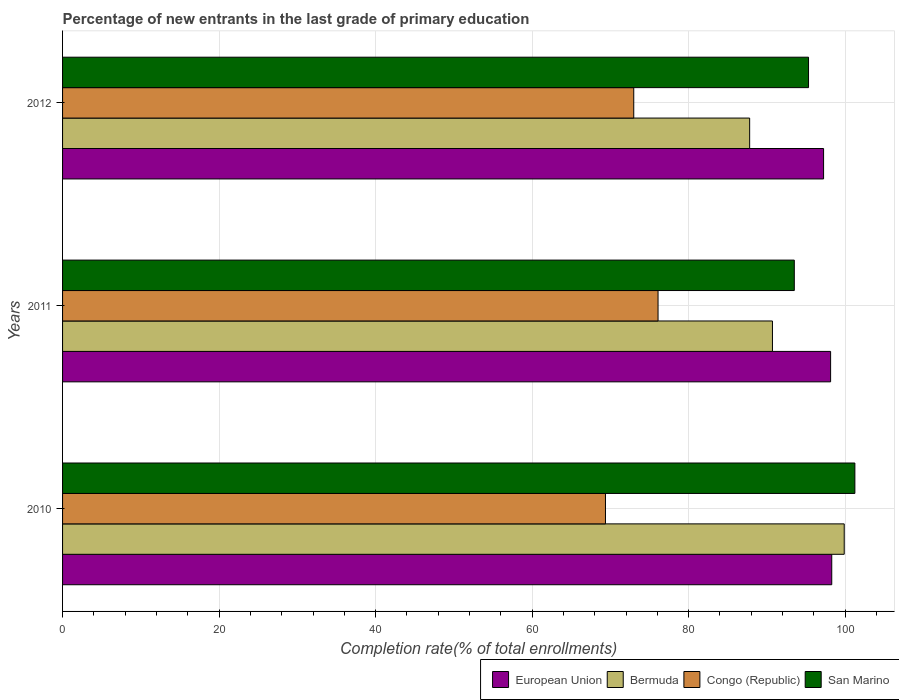How many bars are there on the 3rd tick from the top?
Your response must be concise. 4. How many bars are there on the 1st tick from the bottom?
Make the answer very short. 4. What is the label of the 1st group of bars from the top?
Provide a short and direct response. 2012. What is the percentage of new entrants in European Union in 2011?
Your response must be concise. 98.14. Across all years, what is the maximum percentage of new entrants in San Marino?
Provide a succinct answer. 101.24. Across all years, what is the minimum percentage of new entrants in Bermuda?
Keep it short and to the point. 87.79. In which year was the percentage of new entrants in Bermuda minimum?
Offer a very short reply. 2012. What is the total percentage of new entrants in San Marino in the graph?
Provide a short and direct response. 290.05. What is the difference between the percentage of new entrants in San Marino in 2010 and that in 2012?
Keep it short and to the point. 5.92. What is the difference between the percentage of new entrants in European Union in 2011 and the percentage of new entrants in Bermuda in 2012?
Provide a short and direct response. 10.34. What is the average percentage of new entrants in European Union per year?
Your answer should be very brief. 97.89. In the year 2012, what is the difference between the percentage of new entrants in European Union and percentage of new entrants in San Marino?
Your answer should be compact. 1.92. What is the ratio of the percentage of new entrants in San Marino in 2010 to that in 2012?
Keep it short and to the point. 1.06. Is the percentage of new entrants in Congo (Republic) in 2010 less than that in 2012?
Your response must be concise. Yes. What is the difference between the highest and the second highest percentage of new entrants in San Marino?
Your response must be concise. 5.92. What is the difference between the highest and the lowest percentage of new entrants in San Marino?
Provide a succinct answer. 7.74. In how many years, is the percentage of new entrants in San Marino greater than the average percentage of new entrants in San Marino taken over all years?
Provide a short and direct response. 1. What does the 1st bar from the top in 2010 represents?
Your answer should be compact. San Marino. How many years are there in the graph?
Provide a short and direct response. 3. What is the difference between two consecutive major ticks on the X-axis?
Make the answer very short. 20. Does the graph contain any zero values?
Provide a succinct answer. No. Does the graph contain grids?
Offer a terse response. Yes. Where does the legend appear in the graph?
Provide a short and direct response. Bottom right. What is the title of the graph?
Ensure brevity in your answer.  Percentage of new entrants in the last grade of primary education. What is the label or title of the X-axis?
Offer a terse response. Completion rate(% of total enrollments). What is the label or title of the Y-axis?
Make the answer very short. Years. What is the Completion rate(% of total enrollments) of European Union in 2010?
Give a very brief answer. 98.28. What is the Completion rate(% of total enrollments) in Bermuda in 2010?
Offer a terse response. 99.88. What is the Completion rate(% of total enrollments) of Congo (Republic) in 2010?
Your answer should be compact. 69.37. What is the Completion rate(% of total enrollments) of San Marino in 2010?
Your answer should be very brief. 101.24. What is the Completion rate(% of total enrollments) of European Union in 2011?
Provide a short and direct response. 98.14. What is the Completion rate(% of total enrollments) of Bermuda in 2011?
Keep it short and to the point. 90.71. What is the Completion rate(% of total enrollments) of Congo (Republic) in 2011?
Your answer should be compact. 76.09. What is the Completion rate(% of total enrollments) in San Marino in 2011?
Your answer should be compact. 93.5. What is the Completion rate(% of total enrollments) in European Union in 2012?
Ensure brevity in your answer.  97.24. What is the Completion rate(% of total enrollments) in Bermuda in 2012?
Keep it short and to the point. 87.79. What is the Completion rate(% of total enrollments) of Congo (Republic) in 2012?
Ensure brevity in your answer.  72.98. What is the Completion rate(% of total enrollments) of San Marino in 2012?
Your response must be concise. 95.32. Across all years, what is the maximum Completion rate(% of total enrollments) in European Union?
Provide a short and direct response. 98.28. Across all years, what is the maximum Completion rate(% of total enrollments) of Bermuda?
Your answer should be compact. 99.88. Across all years, what is the maximum Completion rate(% of total enrollments) in Congo (Republic)?
Your answer should be very brief. 76.09. Across all years, what is the maximum Completion rate(% of total enrollments) of San Marino?
Provide a short and direct response. 101.24. Across all years, what is the minimum Completion rate(% of total enrollments) in European Union?
Your answer should be compact. 97.24. Across all years, what is the minimum Completion rate(% of total enrollments) in Bermuda?
Make the answer very short. 87.79. Across all years, what is the minimum Completion rate(% of total enrollments) of Congo (Republic)?
Provide a short and direct response. 69.37. Across all years, what is the minimum Completion rate(% of total enrollments) in San Marino?
Keep it short and to the point. 93.5. What is the total Completion rate(% of total enrollments) of European Union in the graph?
Your response must be concise. 293.66. What is the total Completion rate(% of total enrollments) of Bermuda in the graph?
Provide a short and direct response. 278.37. What is the total Completion rate(% of total enrollments) in Congo (Republic) in the graph?
Your answer should be compact. 218.44. What is the total Completion rate(% of total enrollments) in San Marino in the graph?
Your response must be concise. 290.05. What is the difference between the Completion rate(% of total enrollments) of European Union in 2010 and that in 2011?
Give a very brief answer. 0.15. What is the difference between the Completion rate(% of total enrollments) in Bermuda in 2010 and that in 2011?
Ensure brevity in your answer.  9.17. What is the difference between the Completion rate(% of total enrollments) of Congo (Republic) in 2010 and that in 2011?
Your answer should be very brief. -6.72. What is the difference between the Completion rate(% of total enrollments) in San Marino in 2010 and that in 2011?
Provide a succinct answer. 7.74. What is the difference between the Completion rate(% of total enrollments) of European Union in 2010 and that in 2012?
Keep it short and to the point. 1.04. What is the difference between the Completion rate(% of total enrollments) of Bermuda in 2010 and that in 2012?
Make the answer very short. 12.08. What is the difference between the Completion rate(% of total enrollments) of Congo (Republic) in 2010 and that in 2012?
Provide a succinct answer. -3.61. What is the difference between the Completion rate(% of total enrollments) in San Marino in 2010 and that in 2012?
Your answer should be compact. 5.92. What is the difference between the Completion rate(% of total enrollments) in European Union in 2011 and that in 2012?
Your answer should be compact. 0.9. What is the difference between the Completion rate(% of total enrollments) of Bermuda in 2011 and that in 2012?
Give a very brief answer. 2.91. What is the difference between the Completion rate(% of total enrollments) of Congo (Republic) in 2011 and that in 2012?
Offer a very short reply. 3.11. What is the difference between the Completion rate(% of total enrollments) of San Marino in 2011 and that in 2012?
Your response must be concise. -1.82. What is the difference between the Completion rate(% of total enrollments) in European Union in 2010 and the Completion rate(% of total enrollments) in Bermuda in 2011?
Provide a short and direct response. 7.58. What is the difference between the Completion rate(% of total enrollments) of European Union in 2010 and the Completion rate(% of total enrollments) of Congo (Republic) in 2011?
Offer a very short reply. 22.19. What is the difference between the Completion rate(% of total enrollments) of European Union in 2010 and the Completion rate(% of total enrollments) of San Marino in 2011?
Keep it short and to the point. 4.78. What is the difference between the Completion rate(% of total enrollments) in Bermuda in 2010 and the Completion rate(% of total enrollments) in Congo (Republic) in 2011?
Make the answer very short. 23.79. What is the difference between the Completion rate(% of total enrollments) of Bermuda in 2010 and the Completion rate(% of total enrollments) of San Marino in 2011?
Keep it short and to the point. 6.38. What is the difference between the Completion rate(% of total enrollments) of Congo (Republic) in 2010 and the Completion rate(% of total enrollments) of San Marino in 2011?
Offer a very short reply. -24.13. What is the difference between the Completion rate(% of total enrollments) in European Union in 2010 and the Completion rate(% of total enrollments) in Bermuda in 2012?
Offer a terse response. 10.49. What is the difference between the Completion rate(% of total enrollments) of European Union in 2010 and the Completion rate(% of total enrollments) of Congo (Republic) in 2012?
Offer a very short reply. 25.3. What is the difference between the Completion rate(% of total enrollments) in European Union in 2010 and the Completion rate(% of total enrollments) in San Marino in 2012?
Make the answer very short. 2.97. What is the difference between the Completion rate(% of total enrollments) in Bermuda in 2010 and the Completion rate(% of total enrollments) in Congo (Republic) in 2012?
Make the answer very short. 26.89. What is the difference between the Completion rate(% of total enrollments) of Bermuda in 2010 and the Completion rate(% of total enrollments) of San Marino in 2012?
Your response must be concise. 4.56. What is the difference between the Completion rate(% of total enrollments) in Congo (Republic) in 2010 and the Completion rate(% of total enrollments) in San Marino in 2012?
Provide a succinct answer. -25.95. What is the difference between the Completion rate(% of total enrollments) in European Union in 2011 and the Completion rate(% of total enrollments) in Bermuda in 2012?
Your answer should be compact. 10.34. What is the difference between the Completion rate(% of total enrollments) of European Union in 2011 and the Completion rate(% of total enrollments) of Congo (Republic) in 2012?
Give a very brief answer. 25.15. What is the difference between the Completion rate(% of total enrollments) in European Union in 2011 and the Completion rate(% of total enrollments) in San Marino in 2012?
Offer a very short reply. 2.82. What is the difference between the Completion rate(% of total enrollments) of Bermuda in 2011 and the Completion rate(% of total enrollments) of Congo (Republic) in 2012?
Ensure brevity in your answer.  17.72. What is the difference between the Completion rate(% of total enrollments) of Bermuda in 2011 and the Completion rate(% of total enrollments) of San Marino in 2012?
Offer a very short reply. -4.61. What is the difference between the Completion rate(% of total enrollments) of Congo (Republic) in 2011 and the Completion rate(% of total enrollments) of San Marino in 2012?
Offer a very short reply. -19.23. What is the average Completion rate(% of total enrollments) of European Union per year?
Offer a terse response. 97.89. What is the average Completion rate(% of total enrollments) in Bermuda per year?
Provide a short and direct response. 92.79. What is the average Completion rate(% of total enrollments) in Congo (Republic) per year?
Offer a terse response. 72.81. What is the average Completion rate(% of total enrollments) of San Marino per year?
Make the answer very short. 96.68. In the year 2010, what is the difference between the Completion rate(% of total enrollments) in European Union and Completion rate(% of total enrollments) in Bermuda?
Your answer should be compact. -1.59. In the year 2010, what is the difference between the Completion rate(% of total enrollments) in European Union and Completion rate(% of total enrollments) in Congo (Republic)?
Give a very brief answer. 28.91. In the year 2010, what is the difference between the Completion rate(% of total enrollments) in European Union and Completion rate(% of total enrollments) in San Marino?
Offer a terse response. -2.96. In the year 2010, what is the difference between the Completion rate(% of total enrollments) of Bermuda and Completion rate(% of total enrollments) of Congo (Republic)?
Your answer should be very brief. 30.51. In the year 2010, what is the difference between the Completion rate(% of total enrollments) of Bermuda and Completion rate(% of total enrollments) of San Marino?
Make the answer very short. -1.36. In the year 2010, what is the difference between the Completion rate(% of total enrollments) of Congo (Republic) and Completion rate(% of total enrollments) of San Marino?
Provide a short and direct response. -31.87. In the year 2011, what is the difference between the Completion rate(% of total enrollments) in European Union and Completion rate(% of total enrollments) in Bermuda?
Provide a succinct answer. 7.43. In the year 2011, what is the difference between the Completion rate(% of total enrollments) in European Union and Completion rate(% of total enrollments) in Congo (Republic)?
Ensure brevity in your answer.  22.05. In the year 2011, what is the difference between the Completion rate(% of total enrollments) of European Union and Completion rate(% of total enrollments) of San Marino?
Provide a succinct answer. 4.64. In the year 2011, what is the difference between the Completion rate(% of total enrollments) in Bermuda and Completion rate(% of total enrollments) in Congo (Republic)?
Keep it short and to the point. 14.62. In the year 2011, what is the difference between the Completion rate(% of total enrollments) in Bermuda and Completion rate(% of total enrollments) in San Marino?
Make the answer very short. -2.79. In the year 2011, what is the difference between the Completion rate(% of total enrollments) in Congo (Republic) and Completion rate(% of total enrollments) in San Marino?
Your answer should be compact. -17.41. In the year 2012, what is the difference between the Completion rate(% of total enrollments) in European Union and Completion rate(% of total enrollments) in Bermuda?
Your response must be concise. 9.45. In the year 2012, what is the difference between the Completion rate(% of total enrollments) of European Union and Completion rate(% of total enrollments) of Congo (Republic)?
Ensure brevity in your answer.  24.26. In the year 2012, what is the difference between the Completion rate(% of total enrollments) in European Union and Completion rate(% of total enrollments) in San Marino?
Your answer should be very brief. 1.92. In the year 2012, what is the difference between the Completion rate(% of total enrollments) of Bermuda and Completion rate(% of total enrollments) of Congo (Republic)?
Provide a short and direct response. 14.81. In the year 2012, what is the difference between the Completion rate(% of total enrollments) in Bermuda and Completion rate(% of total enrollments) in San Marino?
Keep it short and to the point. -7.52. In the year 2012, what is the difference between the Completion rate(% of total enrollments) in Congo (Republic) and Completion rate(% of total enrollments) in San Marino?
Provide a short and direct response. -22.33. What is the ratio of the Completion rate(% of total enrollments) of Bermuda in 2010 to that in 2011?
Your answer should be very brief. 1.1. What is the ratio of the Completion rate(% of total enrollments) in Congo (Republic) in 2010 to that in 2011?
Give a very brief answer. 0.91. What is the ratio of the Completion rate(% of total enrollments) of San Marino in 2010 to that in 2011?
Provide a succinct answer. 1.08. What is the ratio of the Completion rate(% of total enrollments) in European Union in 2010 to that in 2012?
Provide a succinct answer. 1.01. What is the ratio of the Completion rate(% of total enrollments) of Bermuda in 2010 to that in 2012?
Offer a terse response. 1.14. What is the ratio of the Completion rate(% of total enrollments) of Congo (Republic) in 2010 to that in 2012?
Offer a terse response. 0.95. What is the ratio of the Completion rate(% of total enrollments) in San Marino in 2010 to that in 2012?
Ensure brevity in your answer.  1.06. What is the ratio of the Completion rate(% of total enrollments) of European Union in 2011 to that in 2012?
Provide a succinct answer. 1.01. What is the ratio of the Completion rate(% of total enrollments) in Bermuda in 2011 to that in 2012?
Your answer should be very brief. 1.03. What is the ratio of the Completion rate(% of total enrollments) of Congo (Republic) in 2011 to that in 2012?
Provide a short and direct response. 1.04. What is the ratio of the Completion rate(% of total enrollments) of San Marino in 2011 to that in 2012?
Your answer should be very brief. 0.98. What is the difference between the highest and the second highest Completion rate(% of total enrollments) in European Union?
Your response must be concise. 0.15. What is the difference between the highest and the second highest Completion rate(% of total enrollments) of Bermuda?
Your answer should be very brief. 9.17. What is the difference between the highest and the second highest Completion rate(% of total enrollments) in Congo (Republic)?
Provide a succinct answer. 3.11. What is the difference between the highest and the second highest Completion rate(% of total enrollments) of San Marino?
Provide a succinct answer. 5.92. What is the difference between the highest and the lowest Completion rate(% of total enrollments) in European Union?
Provide a short and direct response. 1.04. What is the difference between the highest and the lowest Completion rate(% of total enrollments) of Bermuda?
Your answer should be very brief. 12.08. What is the difference between the highest and the lowest Completion rate(% of total enrollments) in Congo (Republic)?
Keep it short and to the point. 6.72. What is the difference between the highest and the lowest Completion rate(% of total enrollments) of San Marino?
Offer a terse response. 7.74. 